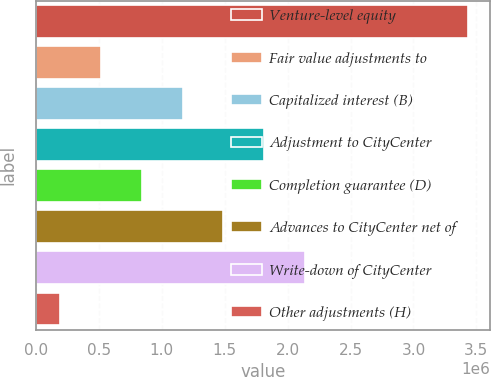<chart> <loc_0><loc_0><loc_500><loc_500><bar_chart><fcel>Venture-level equity<fcel>Fair value adjustments to<fcel>Capitalized interest (B)<fcel>Adjustment to CityCenter<fcel>Completion guarantee (D)<fcel>Advances to CityCenter net of<fcel>Write-down of CityCenter<fcel>Other adjustments (H)<nl><fcel>3.43397e+06<fcel>518619<fcel>1.16647e+06<fcel>1.81433e+06<fcel>842547<fcel>1.4904e+06<fcel>2.13826e+06<fcel>194692<nl></chart> 